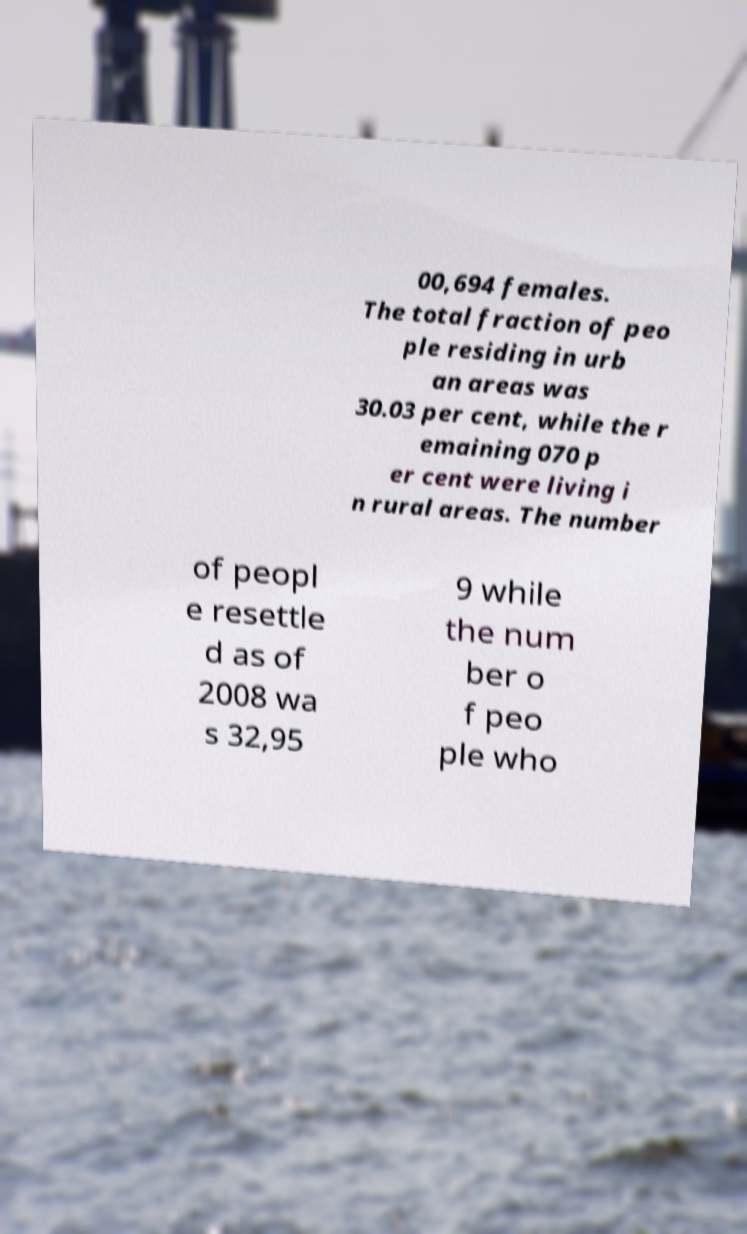Could you assist in decoding the text presented in this image and type it out clearly? 00,694 females. The total fraction of peo ple residing in urb an areas was 30.03 per cent, while the r emaining 070 p er cent were living i n rural areas. The number of peopl e resettle d as of 2008 wa s 32,95 9 while the num ber o f peo ple who 